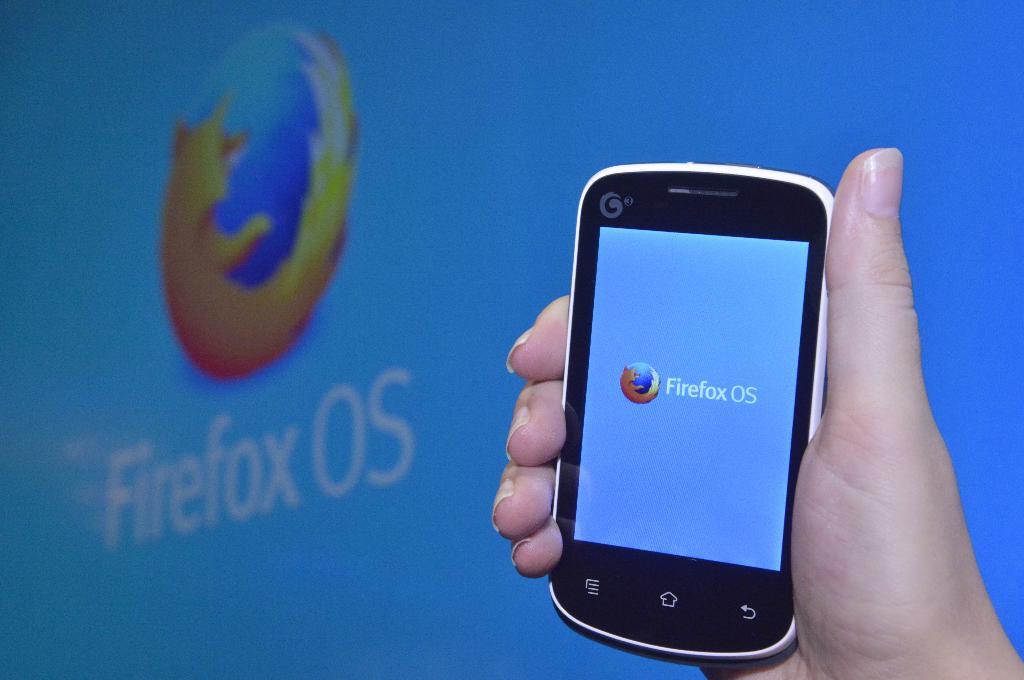What browser is shown in the background?
Give a very brief answer. Firefox. What browser is displayed on the smartphone screen?
Your response must be concise. Firefox. 